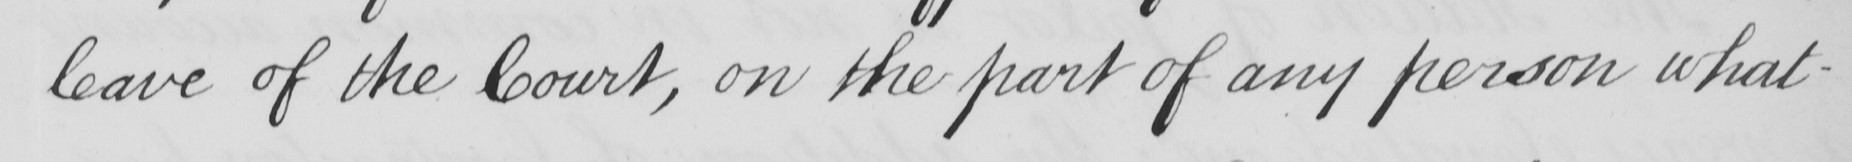What text is written in this handwritten line? leave of the Court , on the part of any person what- 